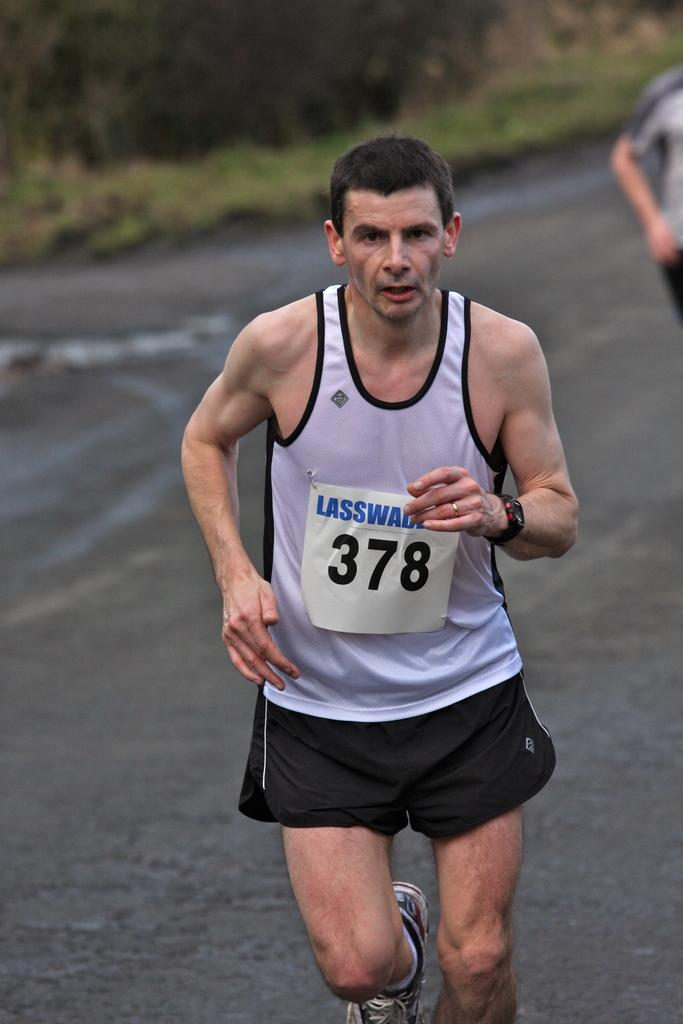<image>
Present a compact description of the photo's key features. the number 378 is on the paper in front of the person 